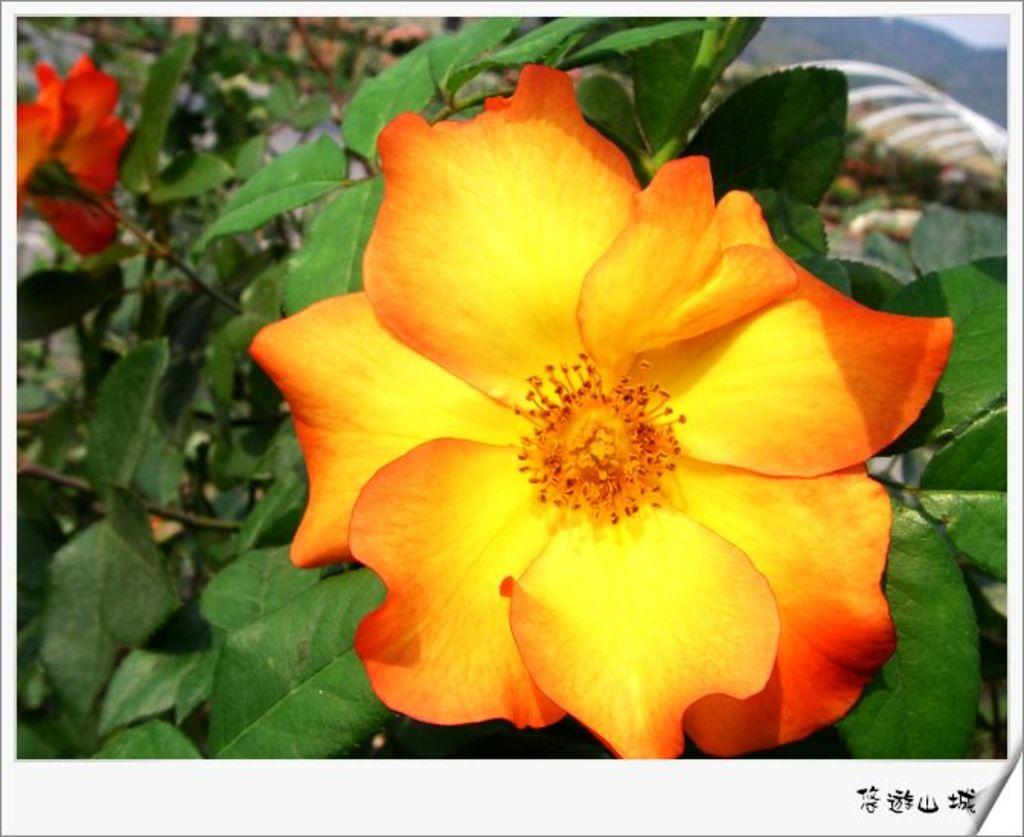What type of plants can be seen in the image? There are plants with flowers in the image. What other features can be observed on the plants? The plants have leaves. Can you describe the background of the image? The background of the image is blurred. Is there any additional information or marking on the image? Yes, there is a watermark on the image. Where is the giraffe in the image? There is no giraffe present in the image. What type of toothbrush is being used by the plants in the image? There are no toothbrushes present in the image, as it features plants with flowers and leaves. 